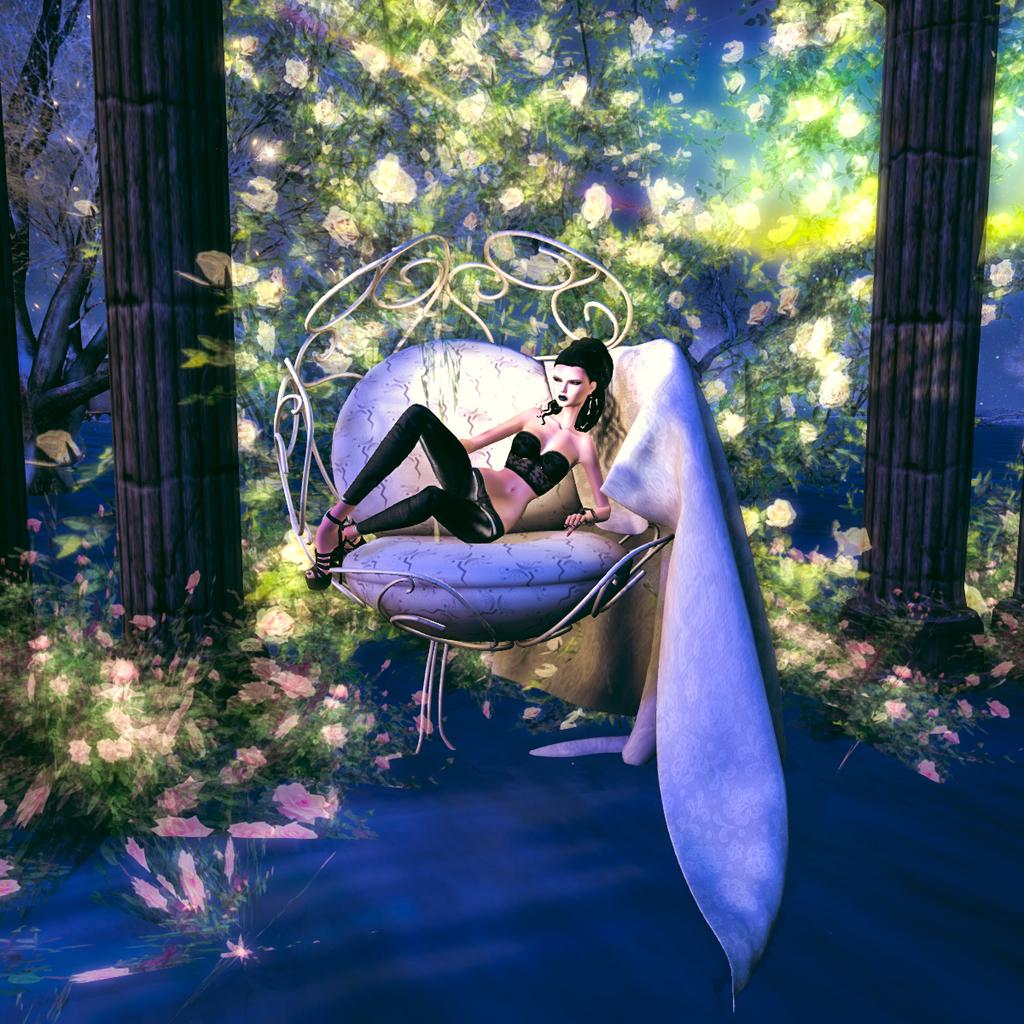What type of image is being described? The image is animated. What is the lady doing in the image? The lady is sitting on an object. What can be seen beneath the lady and the object? The ground is visible in the image. What type of vegetation is present in the image? There are plants, flowers, and trees in the image. What architectural feature can be seen in the image? There are pillars in the image. What is visible in the background of the image? The background is visible in the image. What type of boot is the lady wearing in the image? There is no boot visible in the image; the lady is sitting on an object. How does the lady's muscle strength contribute to the scene in the image? The lady's muscle strength is not mentioned or depicted in the image, so it cannot be determined how it contributes to the scene. 